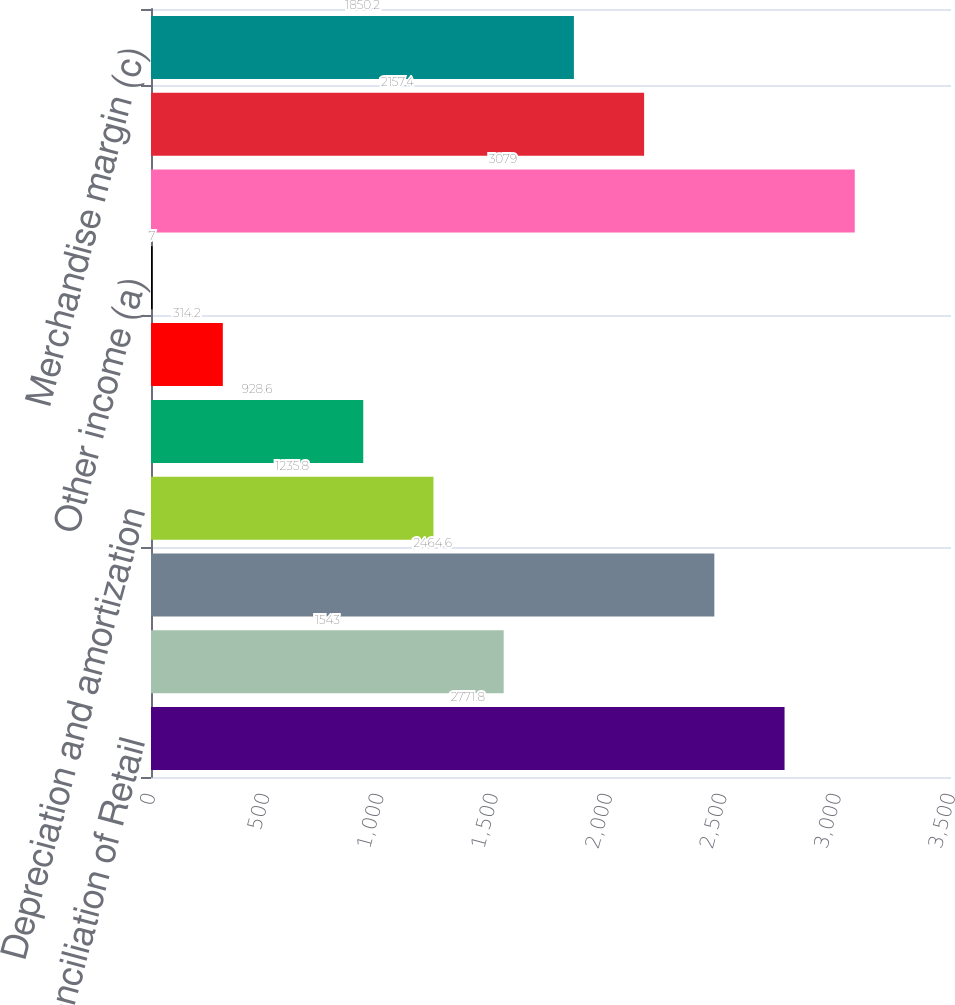Convert chart to OTSL. <chart><loc_0><loc_0><loc_500><loc_500><bar_chart><fcel>Reconciliation of Retail<fcel>Retail income from operations<fcel>Operating selling general and<fcel>Depreciation and amortization<fcel>Income from equity method<fcel>Net gain on disposal of assets<fcel>Other income (a)<fcel>Retail total margin<fcel>Fuel margin (b)<fcel>Merchandise margin (c)<nl><fcel>2771.8<fcel>1543<fcel>2464.6<fcel>1235.8<fcel>928.6<fcel>314.2<fcel>7<fcel>3079<fcel>2157.4<fcel>1850.2<nl></chart> 